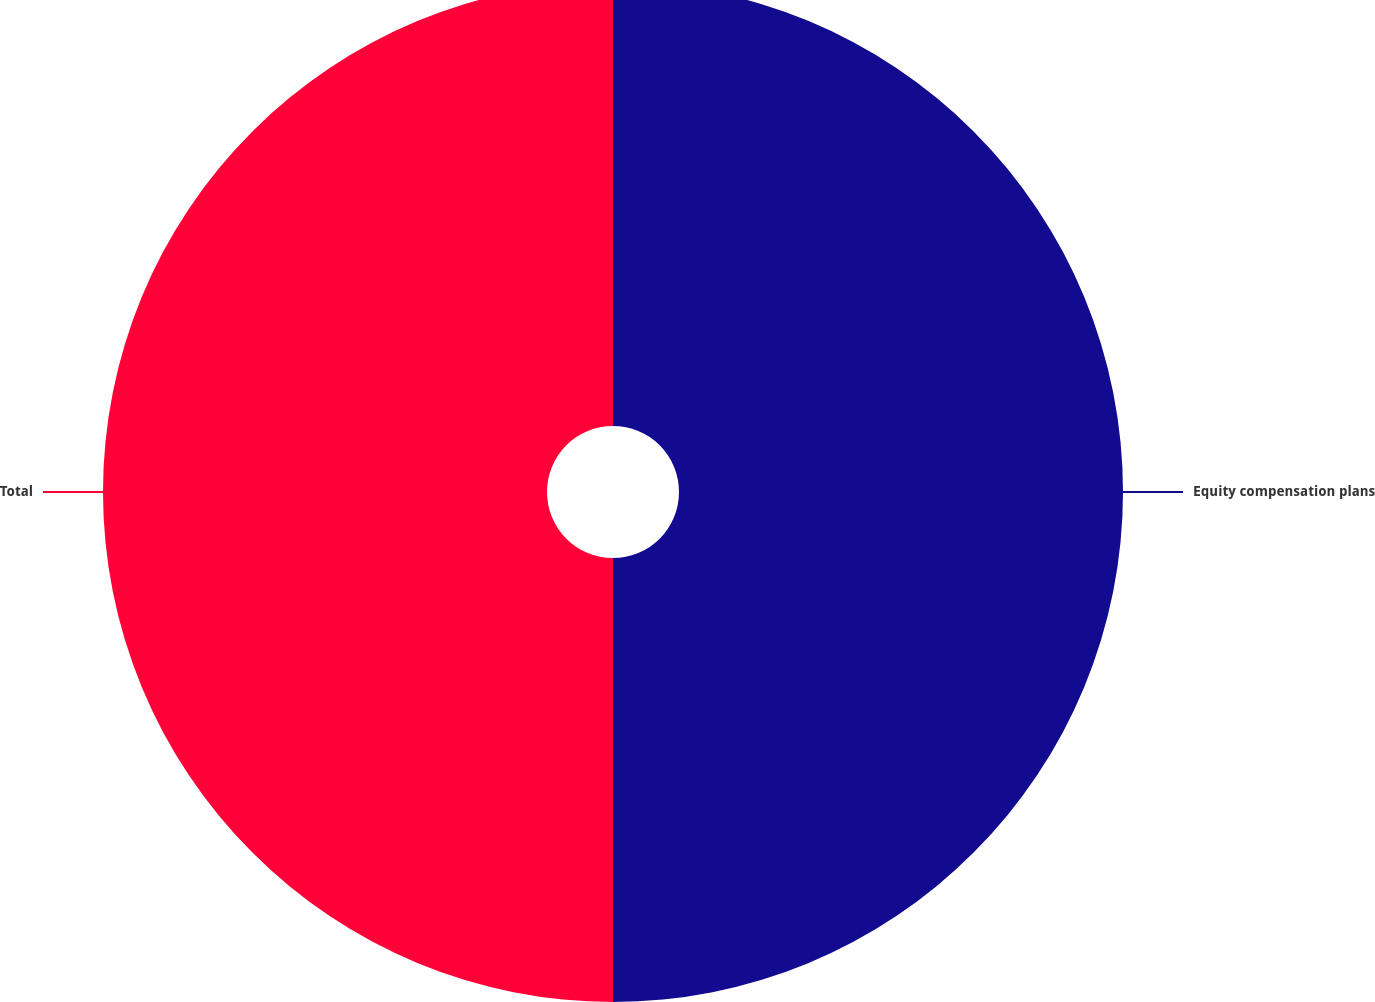Convert chart to OTSL. <chart><loc_0><loc_0><loc_500><loc_500><pie_chart><fcel>Equity compensation plans<fcel>Total<nl><fcel>50.0%<fcel>50.0%<nl></chart> 